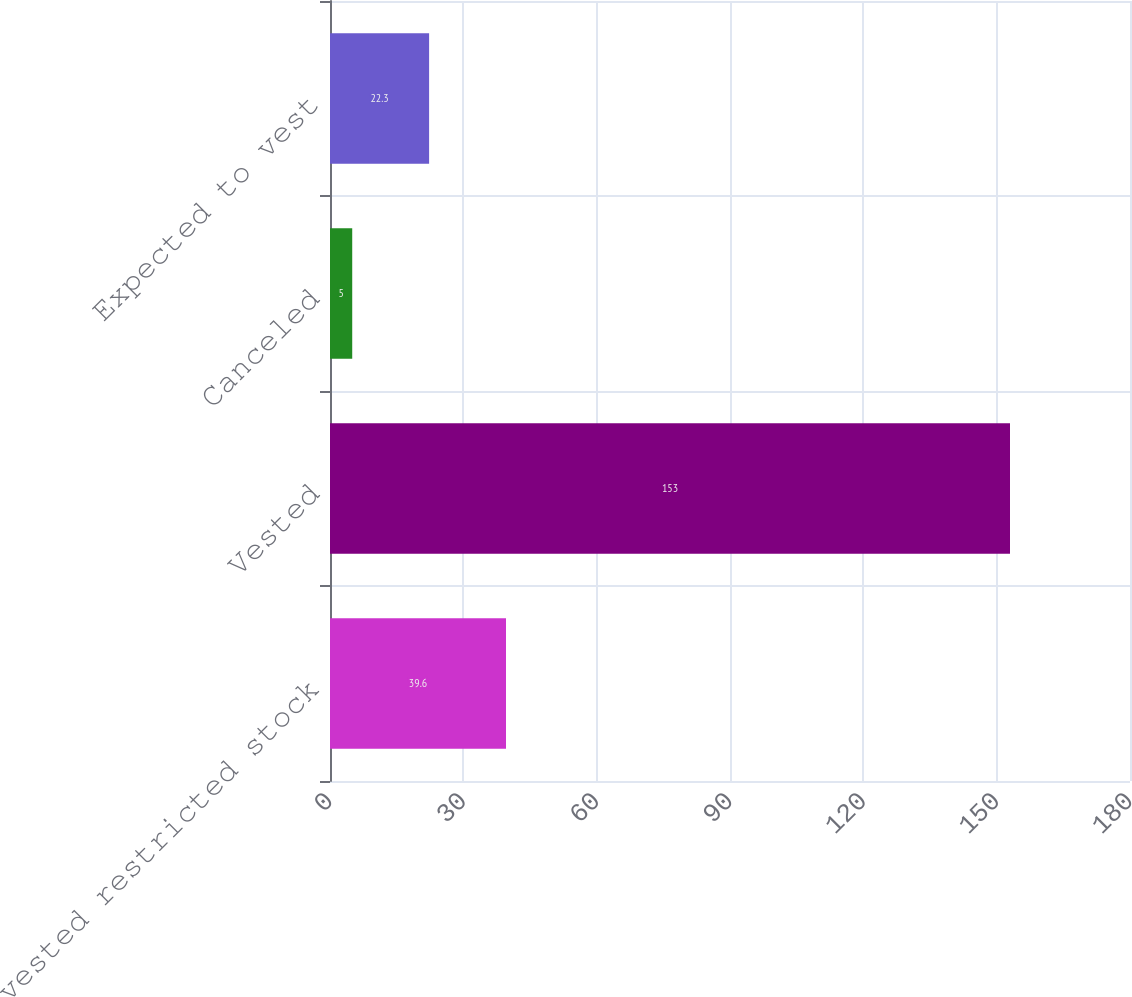Convert chart to OTSL. <chart><loc_0><loc_0><loc_500><loc_500><bar_chart><fcel>Unvested restricted stock<fcel>Vested<fcel>Canceled<fcel>Expected to vest<nl><fcel>39.6<fcel>153<fcel>5<fcel>22.3<nl></chart> 